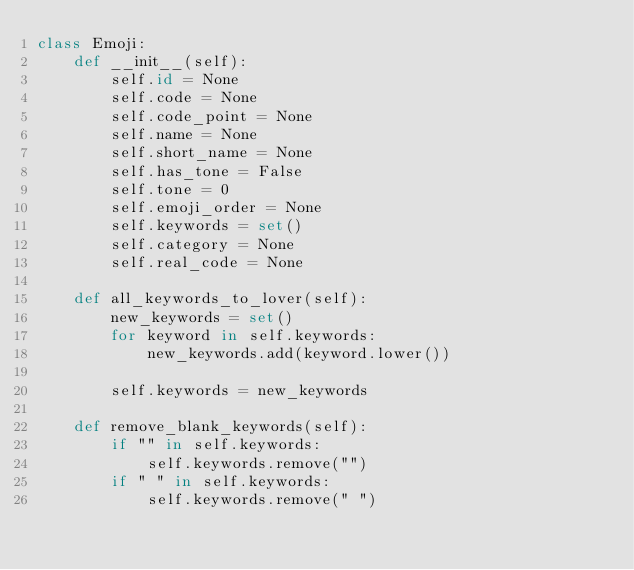Convert code to text. <code><loc_0><loc_0><loc_500><loc_500><_Python_>class Emoji:
    def __init__(self):
        self.id = None
        self.code = None
        self.code_point = None
        self.name = None
        self.short_name = None
        self.has_tone = False
        self.tone = 0
        self.emoji_order = None
        self.keywords = set()
        self.category = None
        self.real_code = None

    def all_keywords_to_lover(self):
        new_keywords = set()
        for keyword in self.keywords:
            new_keywords.add(keyword.lower())

        self.keywords = new_keywords

    def remove_blank_keywords(self):
        if "" in self.keywords:
            self.keywords.remove("")
        if " " in self.keywords:
            self.keywords.remove(" ")

</code> 